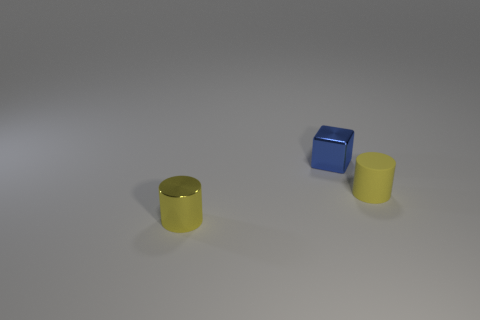What is the shape of the object that is the same color as the metal cylinder?
Your answer should be very brief. Cylinder. What number of objects are either small yellow objects that are to the left of the matte cylinder or yellow cylinders on the left side of the small matte cylinder?
Keep it short and to the point. 1. What number of objects are either tiny yellow cylinders or big green spheres?
Offer a very short reply. 2. What is the size of the object that is both to the right of the small yellow metallic cylinder and left of the tiny yellow rubber thing?
Provide a short and direct response. Small. What number of small objects are made of the same material as the cube?
Make the answer very short. 1. There is a cylinder that is made of the same material as the blue object; what color is it?
Provide a short and direct response. Yellow. Is the color of the small shiny object on the right side of the tiny yellow shiny cylinder the same as the matte cylinder?
Your response must be concise. No. There is a cylinder left of the rubber cylinder; what material is it?
Offer a very short reply. Metal. Are there an equal number of blocks to the right of the small blue shiny cube and cyan objects?
Offer a terse response. Yes. How many other matte cylinders have the same color as the tiny matte cylinder?
Ensure brevity in your answer.  0. 